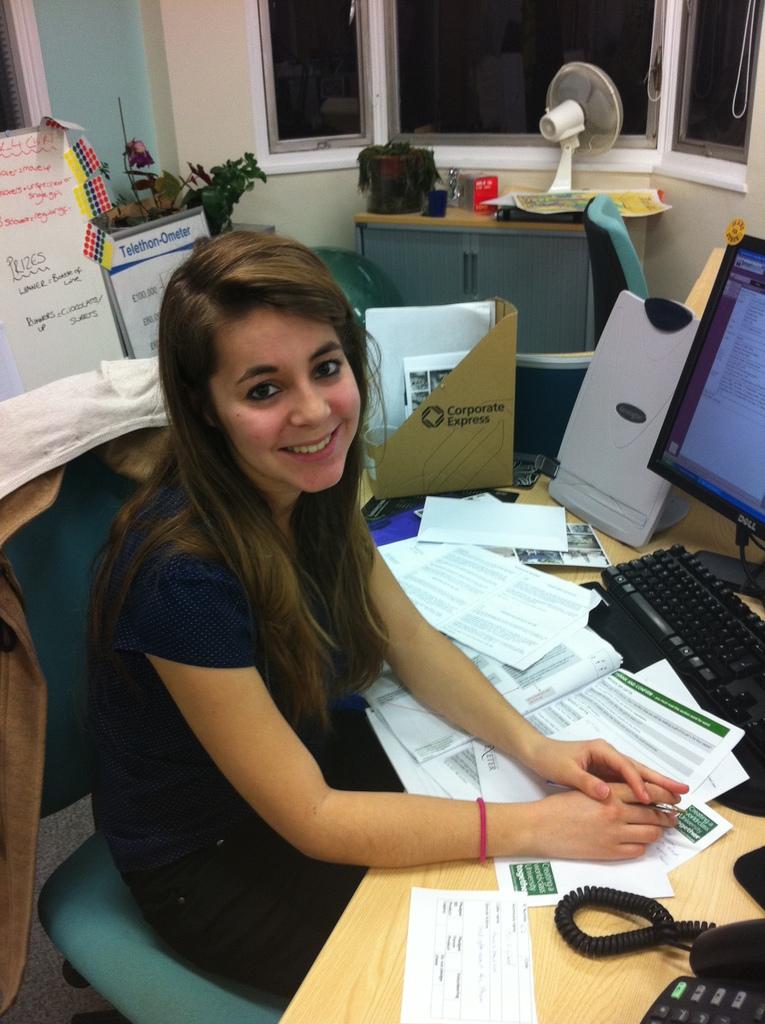What brand is the computer monitor?
Keep it short and to the point. Dell. What type of pc is he using?
Provide a short and direct response. Dell. 